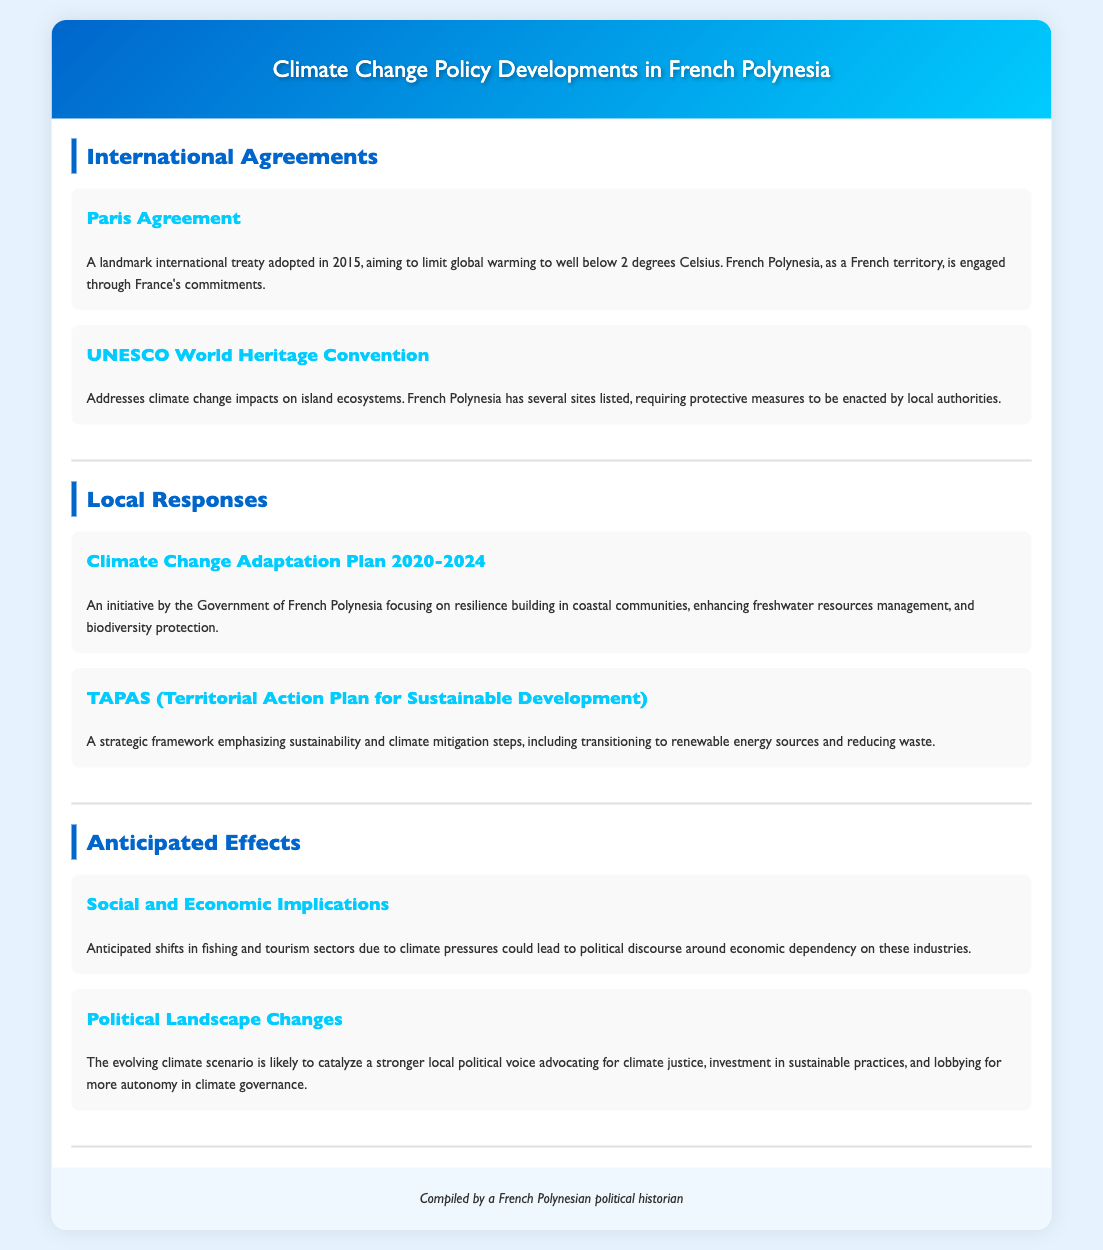What is the Paris Agreement? The Paris Agreement is a landmark international treaty adopted in 2015, aiming to limit global warming to well below 2 degrees Celsius.
Answer: A landmark international treaty adopted in 2015 What does UNESCO World Heritage Convention address? The UNESCO World Heritage Convention addresses climate change impacts on island ecosystems where French Polynesia has several sites listed.
Answer: Climate change impacts on island ecosystems What is the timeframe for the Climate Change Adaptation Plan? The Climate Change Adaptation Plan covers the years 2020 to 2024.
Answer: 2020-2024 What is TAPAS? TAPAS is a strategic framework emphasizing sustainability and climate mitigation steps.
Answer: A strategic framework emphasizing sustainability What could lead to political discourse in French Polynesia? Anticipated shifts in fishing and tourism sectors due to climate pressures could lead to political discourse around economic dependency.
Answer: Shifts in fishing and tourism sectors What is likely to catalyze a stronger local political voice? The evolving climate scenario is likely to catalyze a stronger local political voice advocating for climate justice.
Answer: The evolving climate scenario What is the primary goal of the Climate Change Adaptation Plan? The primary goal is focusing on resilience building in coastal communities, enhancing freshwater resources management, and biodiversity protection.
Answer: Resilience building in coastal communities 